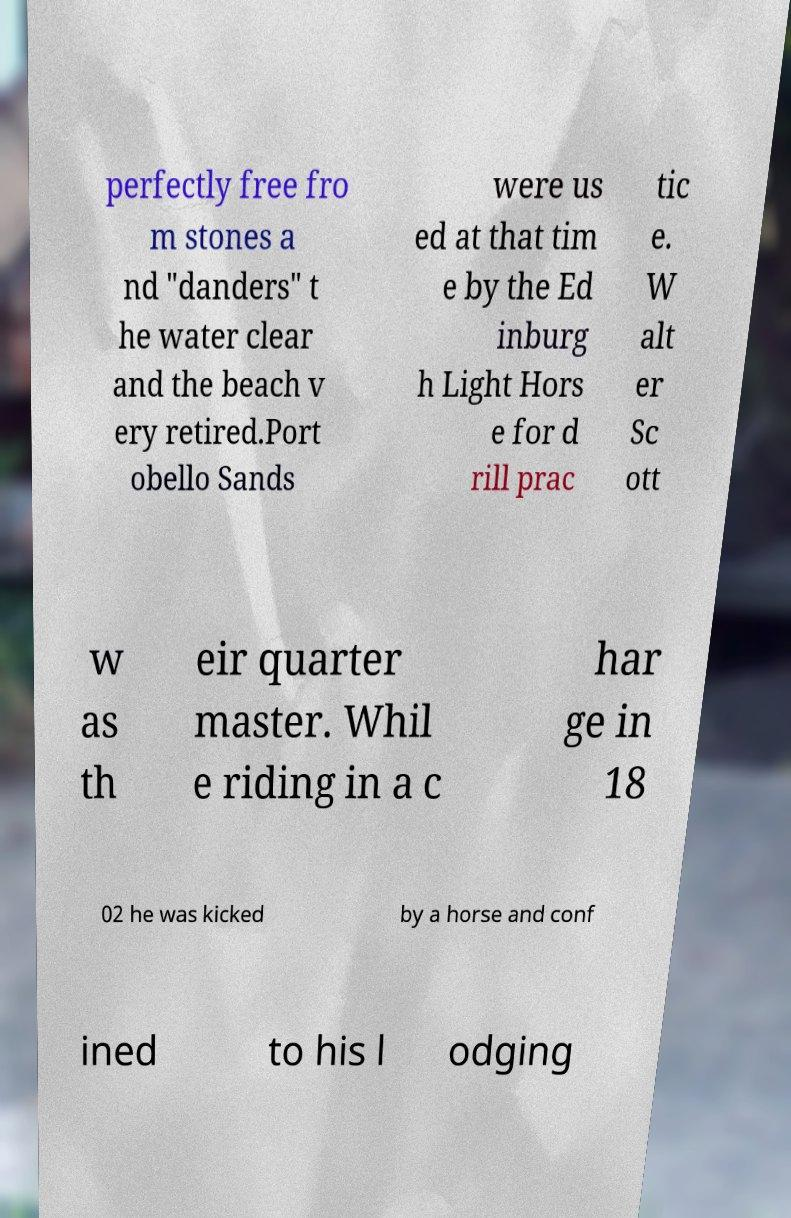Please read and relay the text visible in this image. What does it say? perfectly free fro m stones a nd "danders" t he water clear and the beach v ery retired.Port obello Sands were us ed at that tim e by the Ed inburg h Light Hors e for d rill prac tic e. W alt er Sc ott w as th eir quarter master. Whil e riding in a c har ge in 18 02 he was kicked by a horse and conf ined to his l odging 